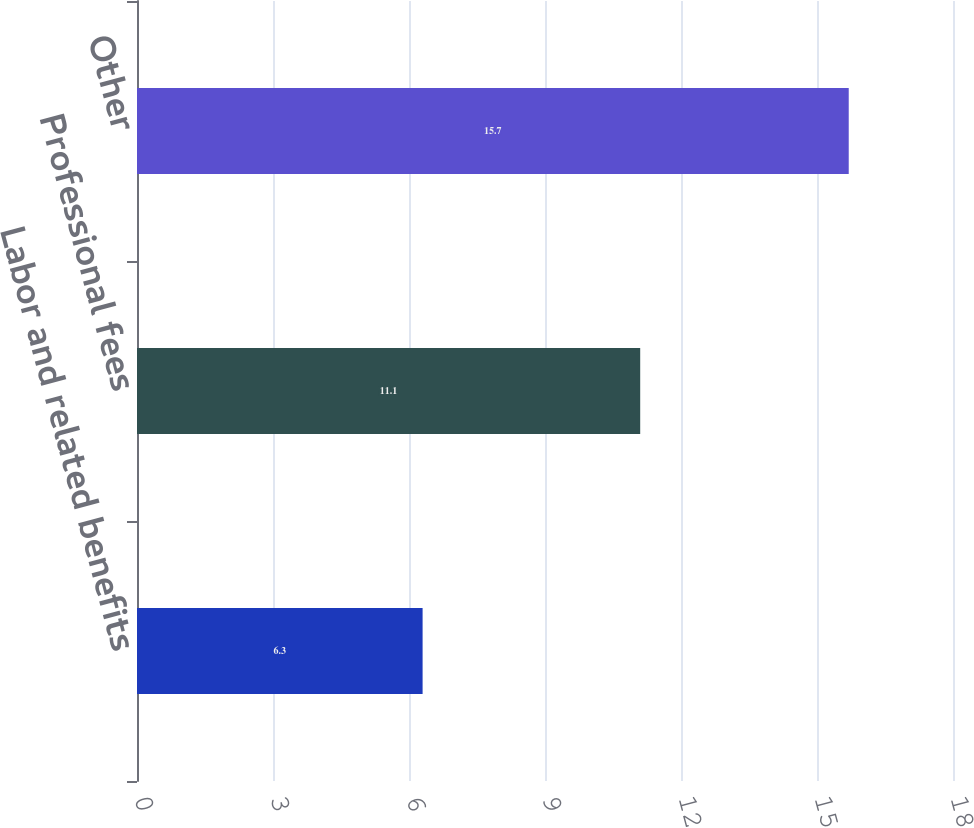Convert chart to OTSL. <chart><loc_0><loc_0><loc_500><loc_500><bar_chart><fcel>Labor and related benefits<fcel>Professional fees<fcel>Other<nl><fcel>6.3<fcel>11.1<fcel>15.7<nl></chart> 